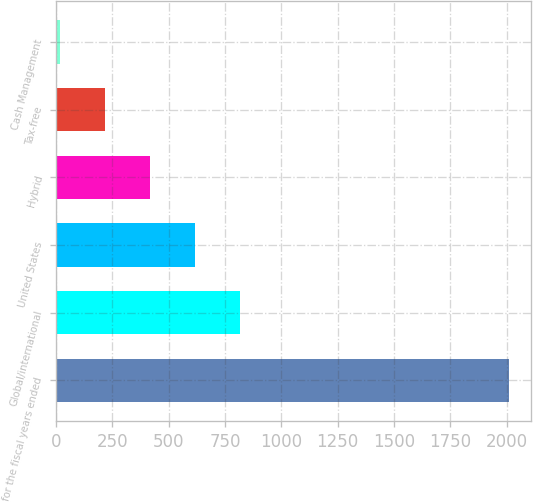<chart> <loc_0><loc_0><loc_500><loc_500><bar_chart><fcel>for the fiscal years ended<fcel>Global/international<fcel>United States<fcel>Hybrid<fcel>Tax-free<fcel>Cash Management<nl><fcel>2009<fcel>815.6<fcel>616.7<fcel>417.8<fcel>218.9<fcel>20<nl></chart> 